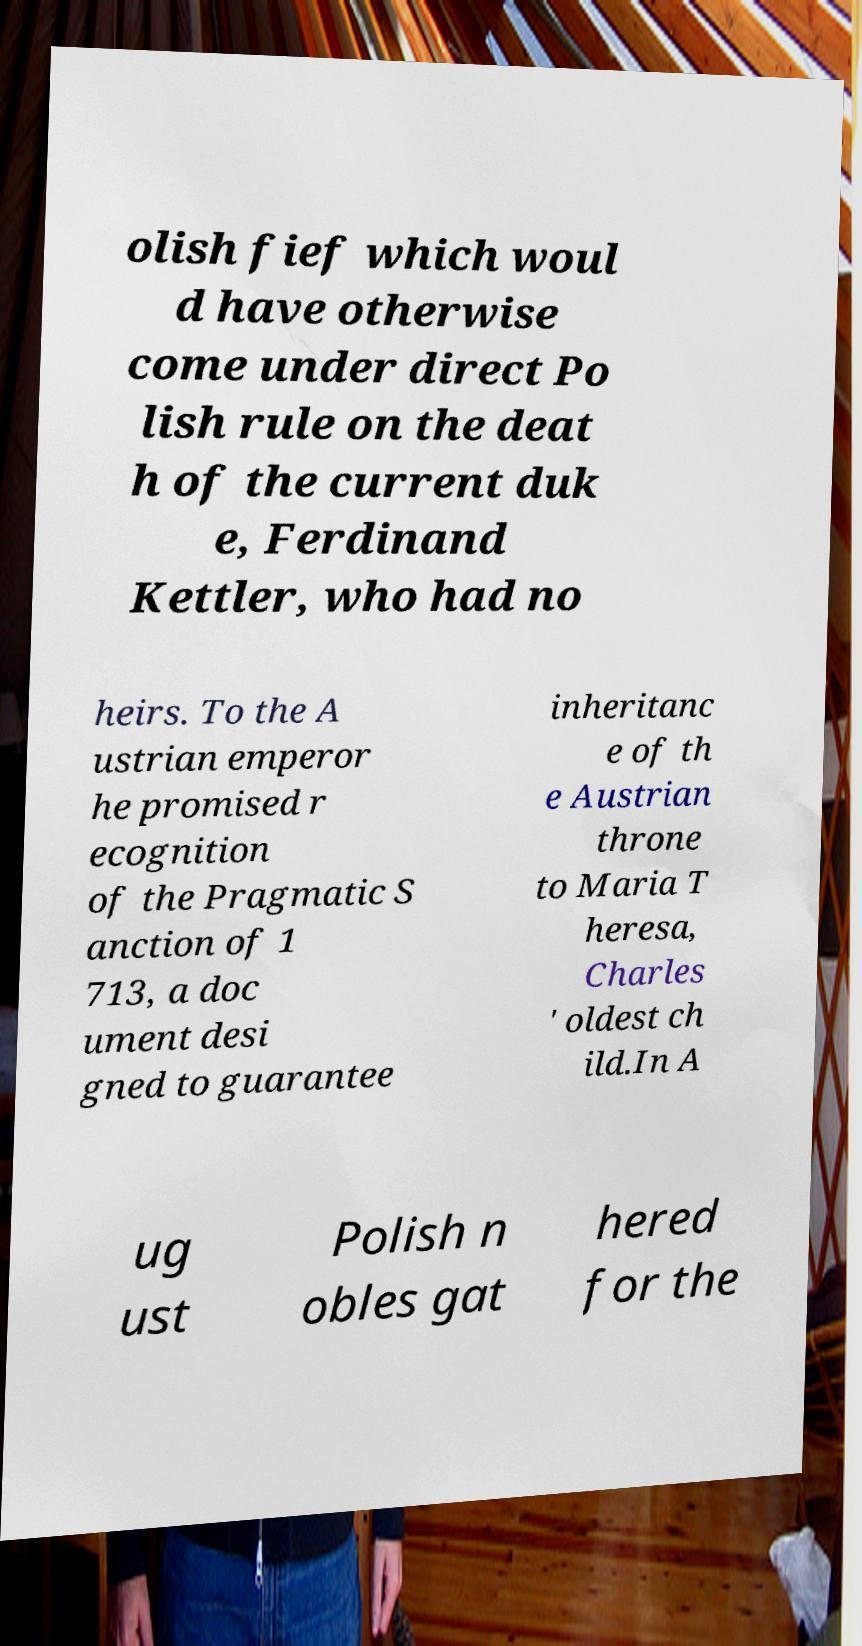Could you assist in decoding the text presented in this image and type it out clearly? olish fief which woul d have otherwise come under direct Po lish rule on the deat h of the current duk e, Ferdinand Kettler, who had no heirs. To the A ustrian emperor he promised r ecognition of the Pragmatic S anction of 1 713, a doc ument desi gned to guarantee inheritanc e of th e Austrian throne to Maria T heresa, Charles ' oldest ch ild.In A ug ust Polish n obles gat hered for the 